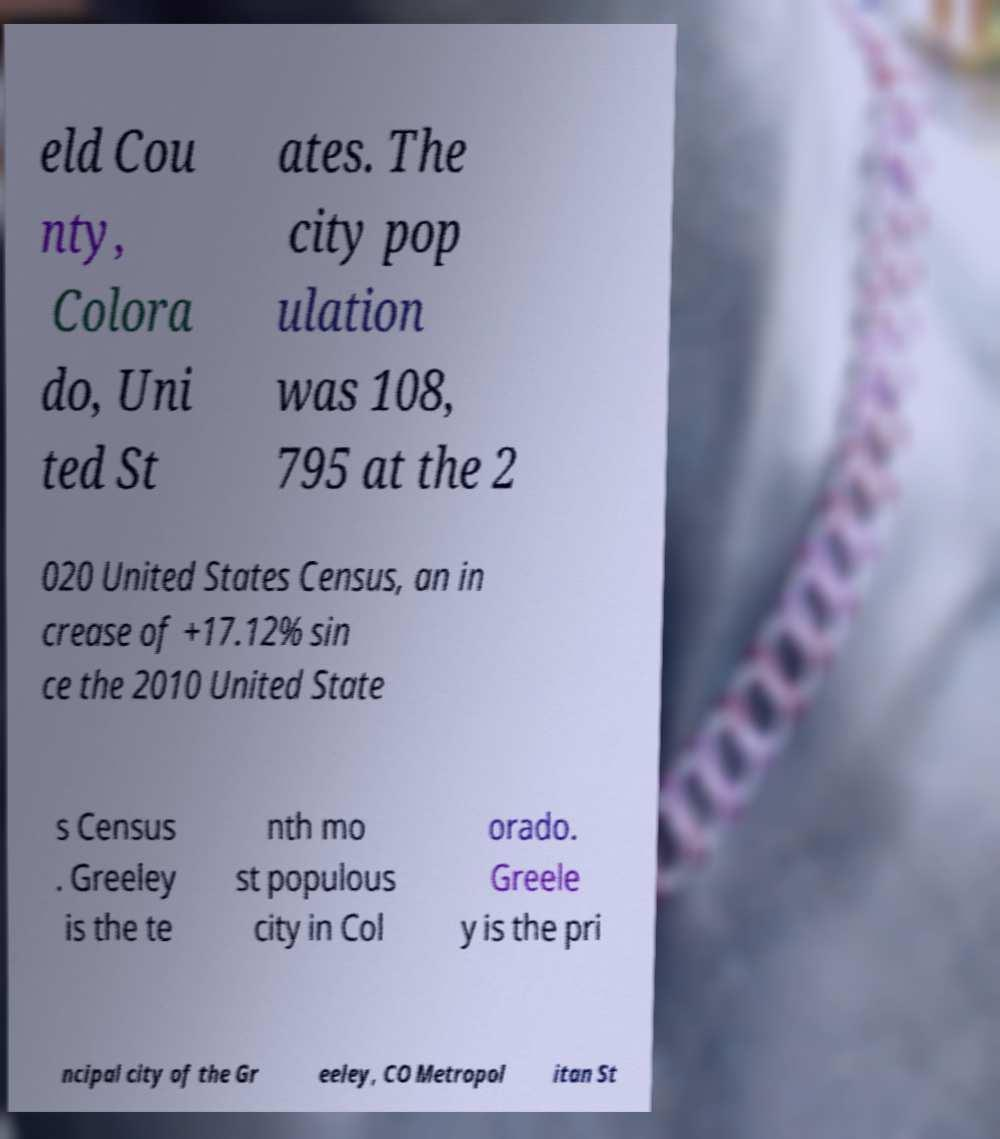There's text embedded in this image that I need extracted. Can you transcribe it verbatim? eld Cou nty, Colora do, Uni ted St ates. The city pop ulation was 108, 795 at the 2 020 United States Census, an in crease of +17.12% sin ce the 2010 United State s Census . Greeley is the te nth mo st populous city in Col orado. Greele y is the pri ncipal city of the Gr eeley, CO Metropol itan St 